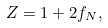<formula> <loc_0><loc_0><loc_500><loc_500>Z = 1 + 2 f _ { N } ,</formula> 